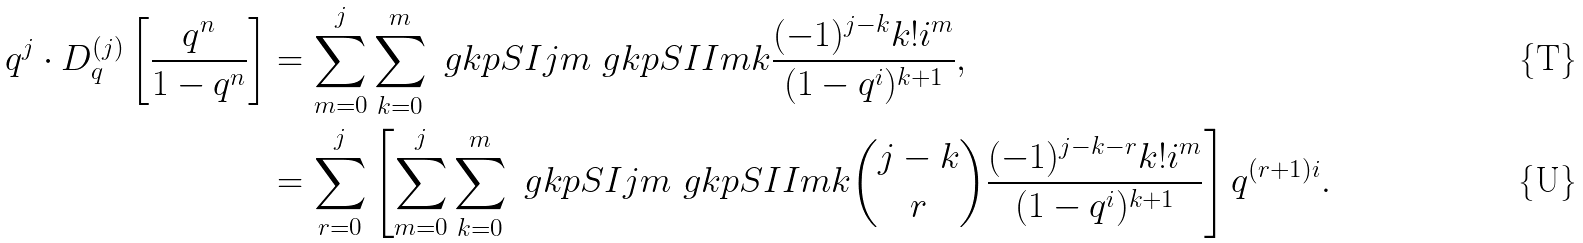Convert formula to latex. <formula><loc_0><loc_0><loc_500><loc_500>q ^ { j } \cdot D _ { q } ^ { ( j ) } \left [ \frac { q ^ { n } } { 1 - q ^ { n } } \right ] & = \sum _ { m = 0 } ^ { j } \sum _ { k = 0 } ^ { m } \ g k p S I { j } { m } \ g k p S I I { m } { k } \frac { ( - 1 ) ^ { j - k } k ! i ^ { m } } { ( 1 - q ^ { i } ) ^ { k + 1 } } , \\ & = \sum _ { r = 0 } ^ { j } \left [ \sum _ { m = 0 } ^ { j } \sum _ { k = 0 } ^ { m } \ g k p S I { j } { m } \ g k p S I I { m } { k } \binom { j - k } { r } \frac { ( - 1 ) ^ { j - k - r } k ! i ^ { m } } { ( 1 - q ^ { i } ) ^ { k + 1 } } \right ] q ^ { ( r + 1 ) i } .</formula> 